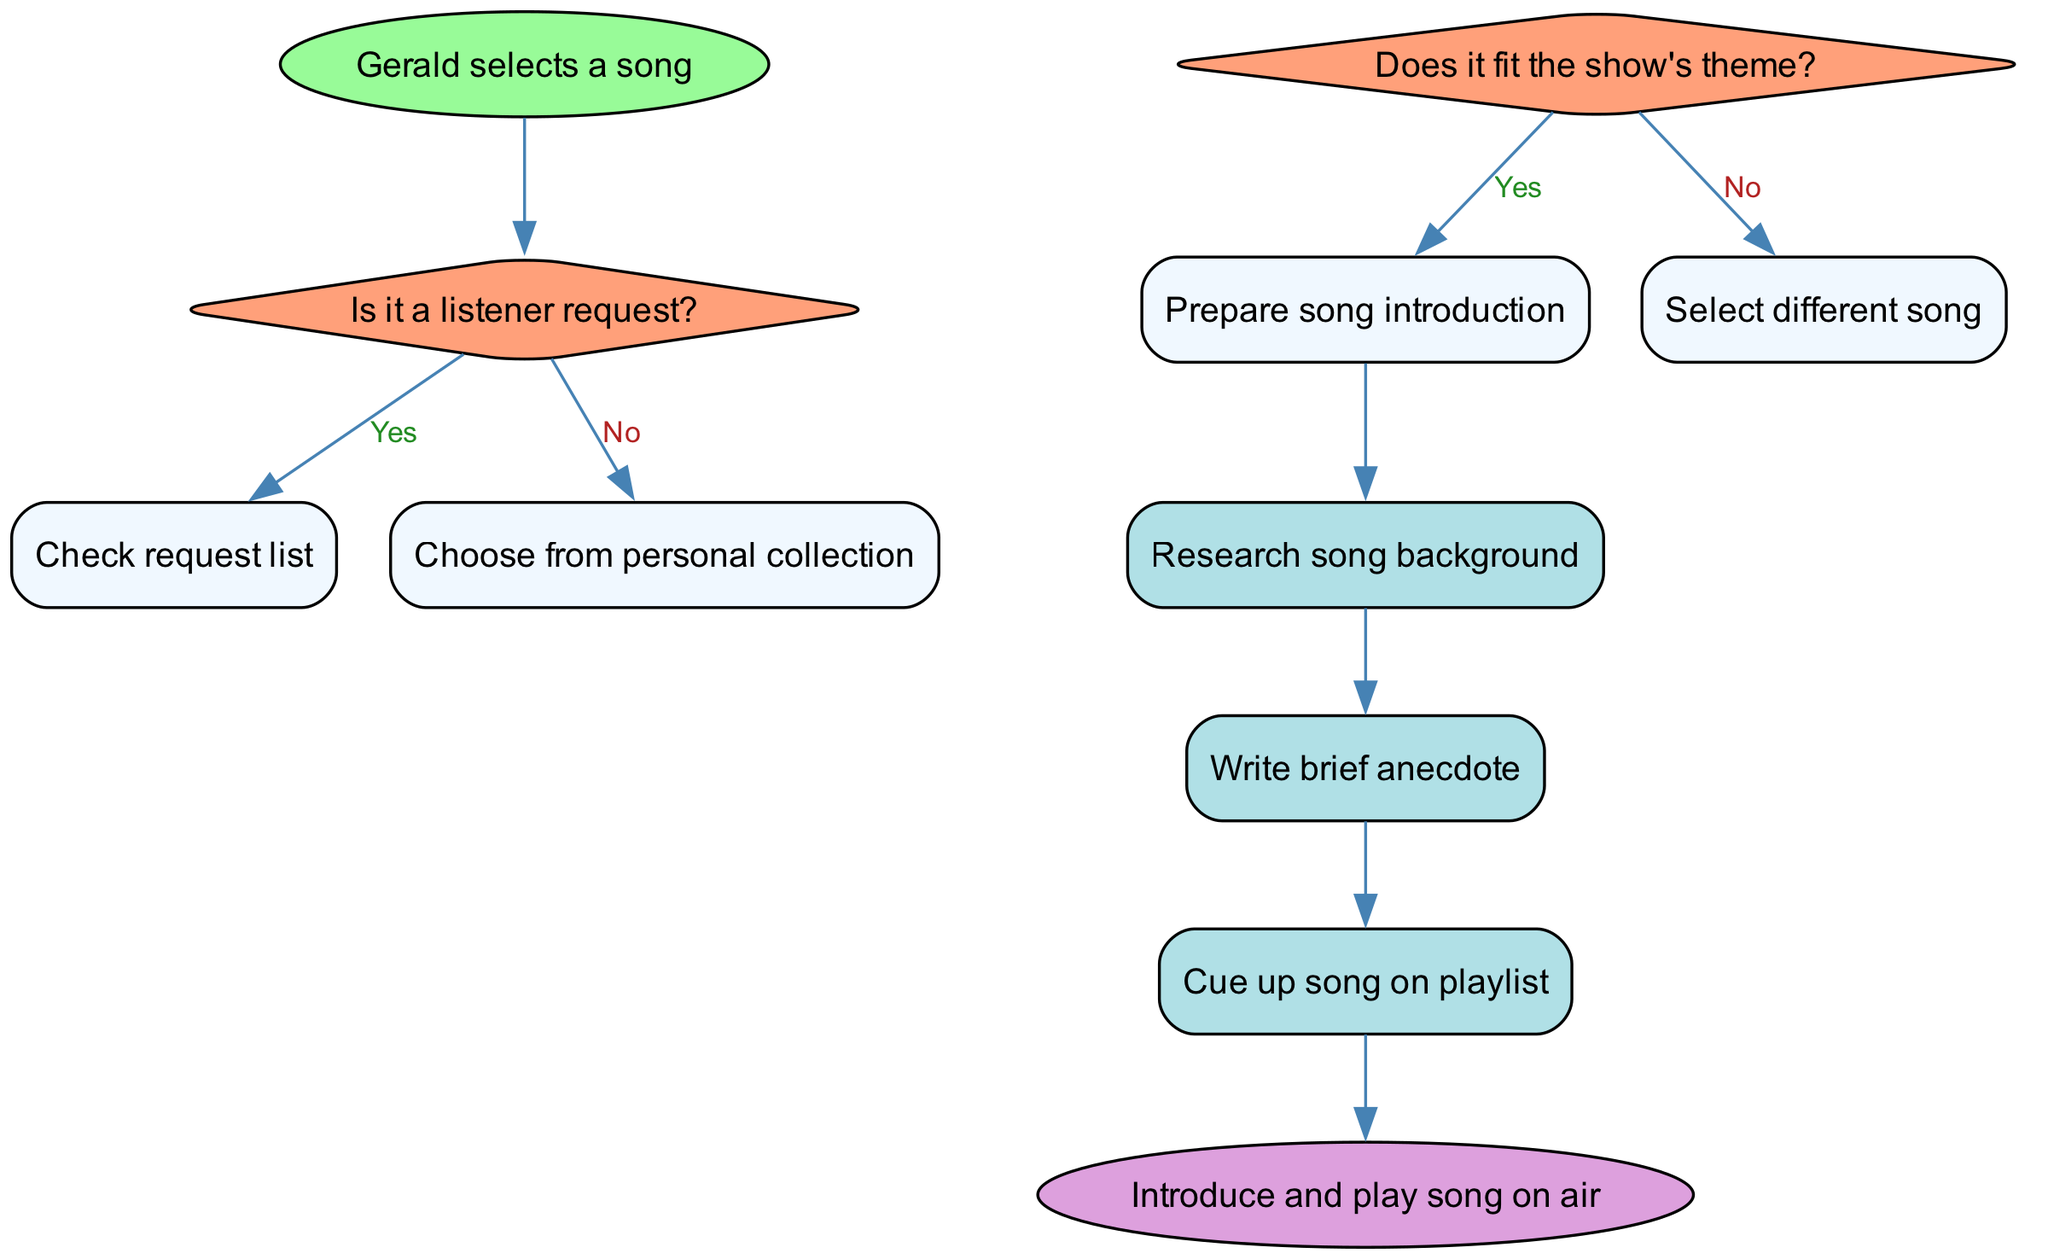What is the starting point of the diagram? The starting point of the diagram is the node labeled "Gerald selects a song," which clearly indicates the initial action in the song selection process.
Answer: Gerald selects a song How many decision nodes are present in the diagram? There are two decision nodes, one that asks if it's a listener request and another that checks if the song fits the show's theme.
Answer: 2 What action follows if the song fits the show's theme? If the song fits the show's theme, the following action is to "Prepare song introduction," which directly links from the corresponding decision node.
Answer: Prepare song introduction What action is performed right before the song is played on air? The action performed right before the song is played on air is "Cue up song on playlist," which is the last action in the sequence before reaching the end node.
Answer: Cue up song on playlist What happens if a song does not fit the show's theme? If a song does not fit the show's theme, the flow indicates that a different song is selected, which leads to searching for another song option in the process.
Answer: Select different song What is the end point of the diagram? The end point of the diagram is identified as "Introduce and play song on air," which signifies the conclusion of the song selection and introduction process.
Answer: Introduce and play song on air What color is used to represent action nodes in the diagram? The action nodes are represented in a light blue color, specifically using the fill color "#B0E0E6," indicating their distinct role in the flow.
Answer: Light blue If the song is a listener request, what is the immediate next step? If the song is a listener request, the immediate next step is to "Check request list," which is the action that directly follows this decision.
Answer: Check request list What is the last action in the sequence before the end? The last action in the sequence before reaching the end of the diagram is to "Cue up song on playlist," linking directly to the final introduction of the song.
Answer: Cue up song on playlist 